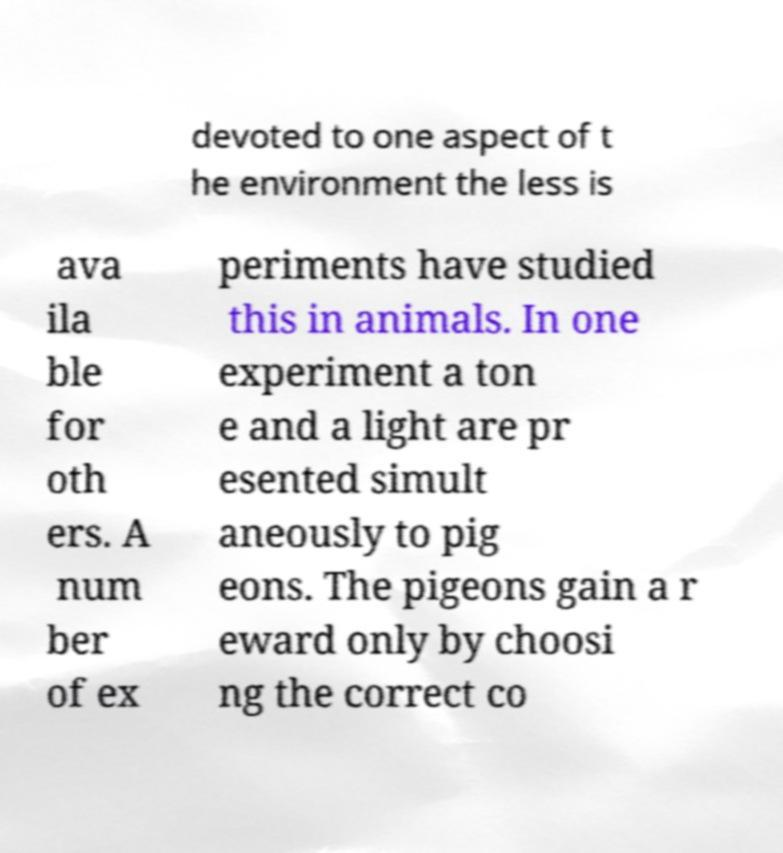I need the written content from this picture converted into text. Can you do that? devoted to one aspect of t he environment the less is ava ila ble for oth ers. A num ber of ex periments have studied this in animals. In one experiment a ton e and a light are pr esented simult aneously to pig eons. The pigeons gain a r eward only by choosi ng the correct co 